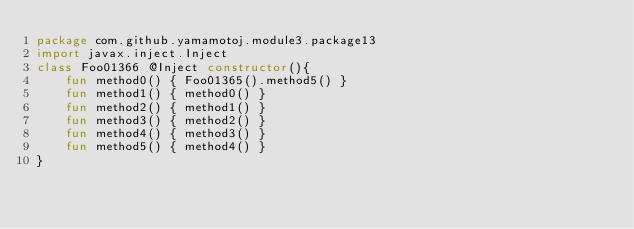Convert code to text. <code><loc_0><loc_0><loc_500><loc_500><_Kotlin_>package com.github.yamamotoj.module3.package13
import javax.inject.Inject
class Foo01366 @Inject constructor(){
    fun method0() { Foo01365().method5() }
    fun method1() { method0() }
    fun method2() { method1() }
    fun method3() { method2() }
    fun method4() { method3() }
    fun method5() { method4() }
}
</code> 